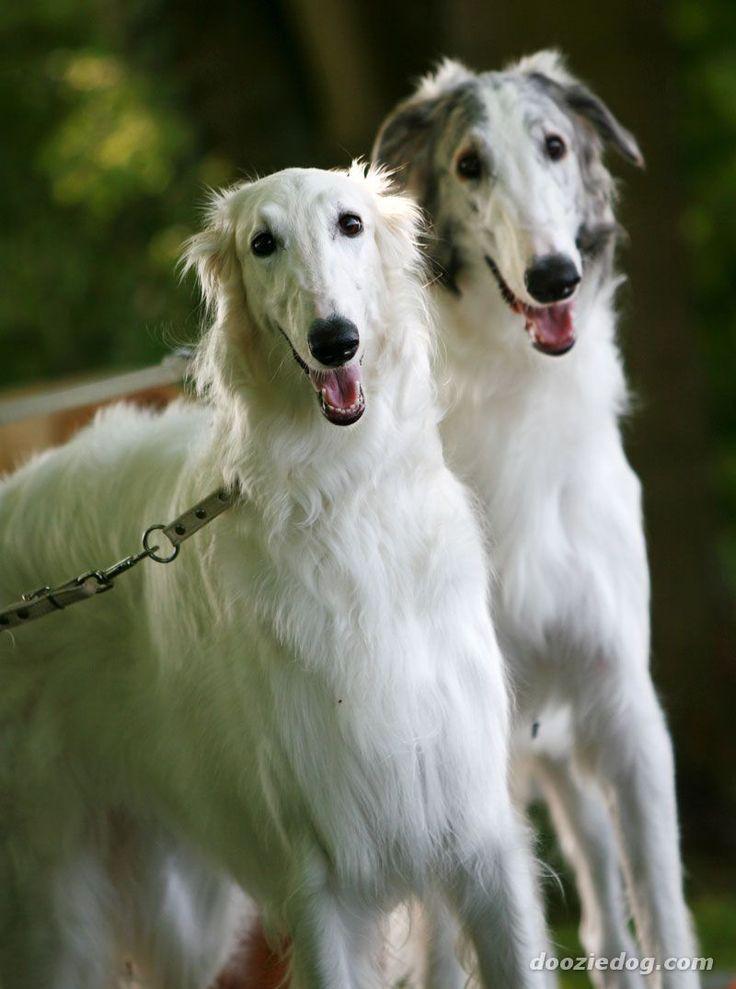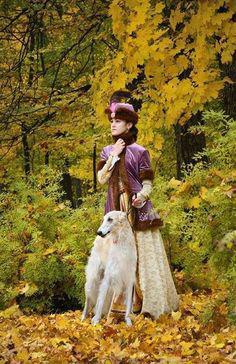The first image is the image on the left, the second image is the image on the right. Considering the images on both sides, is "There are two women, and each has at least one dog." valid? Answer yes or no. No. The first image is the image on the left, the second image is the image on the right. Assess this claim about the two images: "One of the photos shows two dogs and no people.". Correct or not? Answer yes or no. Yes. 